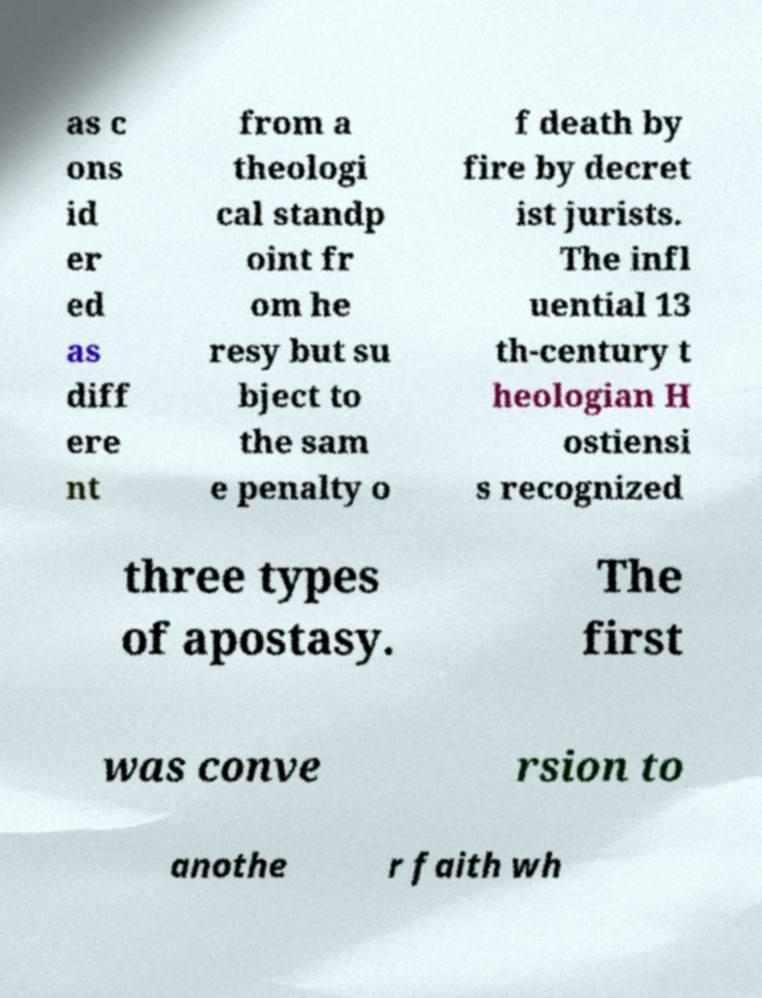There's text embedded in this image that I need extracted. Can you transcribe it verbatim? as c ons id er ed as diff ere nt from a theologi cal standp oint fr om he resy but su bject to the sam e penalty o f death by fire by decret ist jurists. The infl uential 13 th-century t heologian H ostiensi s recognized three types of apostasy. The first was conve rsion to anothe r faith wh 